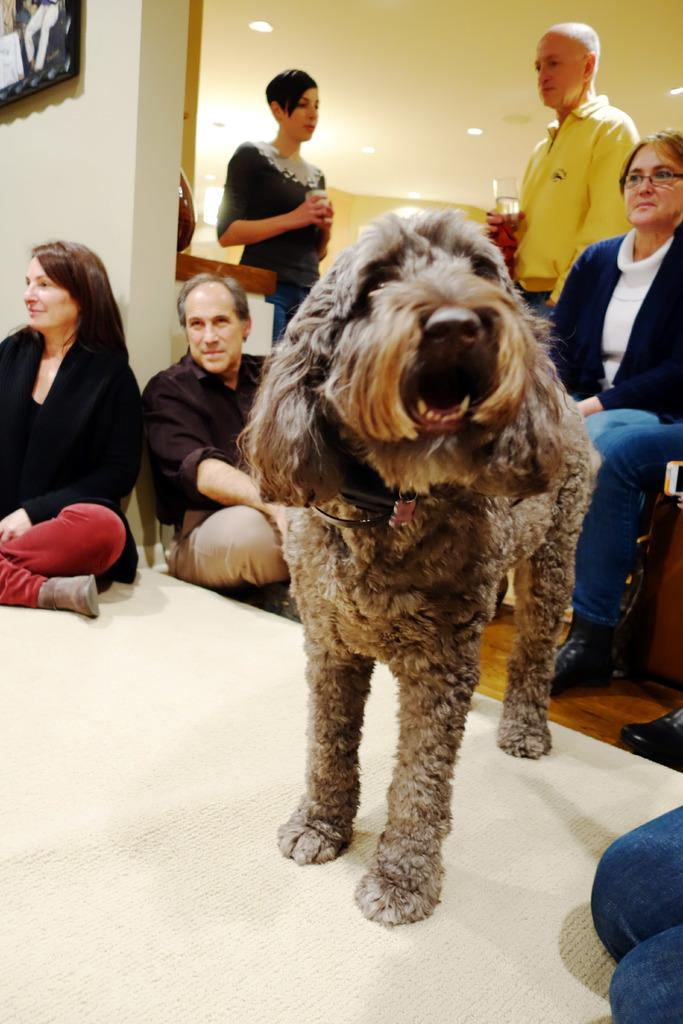What is the main subject of the image? The main subject of the image is a dog standing on the carpet. What are the persons in the image doing? The persons in the image are sitting and standing on the floor. What objects are present in the image that can be used for sitting? There are chairs in the image that can be used for sitting. What are the persons holding in their hands? The persons are holding glass tumblers in their hands. What type of map can be seen on the dog's elbow in the image? There is no map present in the image, and the dog does not have an elbow. 